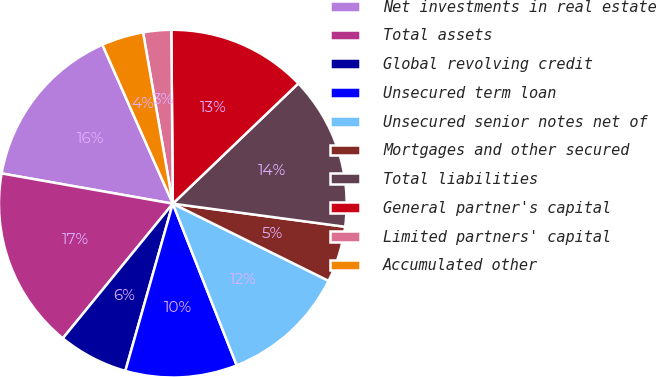Convert chart to OTSL. <chart><loc_0><loc_0><loc_500><loc_500><pie_chart><fcel>Net investments in real estate<fcel>Total assets<fcel>Global revolving credit<fcel>Unsecured term loan<fcel>Unsecured senior notes net of<fcel>Mortgages and other secured<fcel>Total liabilities<fcel>General partner's capital<fcel>Limited partners' capital<fcel>Accumulated other<nl><fcel>15.58%<fcel>16.88%<fcel>6.5%<fcel>10.39%<fcel>11.69%<fcel>5.2%<fcel>14.28%<fcel>12.98%<fcel>2.6%<fcel>3.9%<nl></chart> 